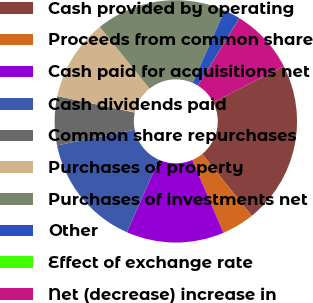<chart> <loc_0><loc_0><loc_500><loc_500><pie_chart><fcel>Cash provided by operating<fcel>Proceeds from common share<fcel>Cash paid for acquisitions net<fcel>Cash dividends paid<fcel>Common share repurchases<fcel>Purchases of property<fcel>Purchases of investments net<fcel>Other<fcel>Effect of exchange rate<fcel>Net (decrease) increase in<nl><fcel>21.73%<fcel>4.35%<fcel>13.04%<fcel>15.21%<fcel>6.52%<fcel>10.87%<fcel>17.39%<fcel>2.18%<fcel>0.01%<fcel>8.7%<nl></chart> 